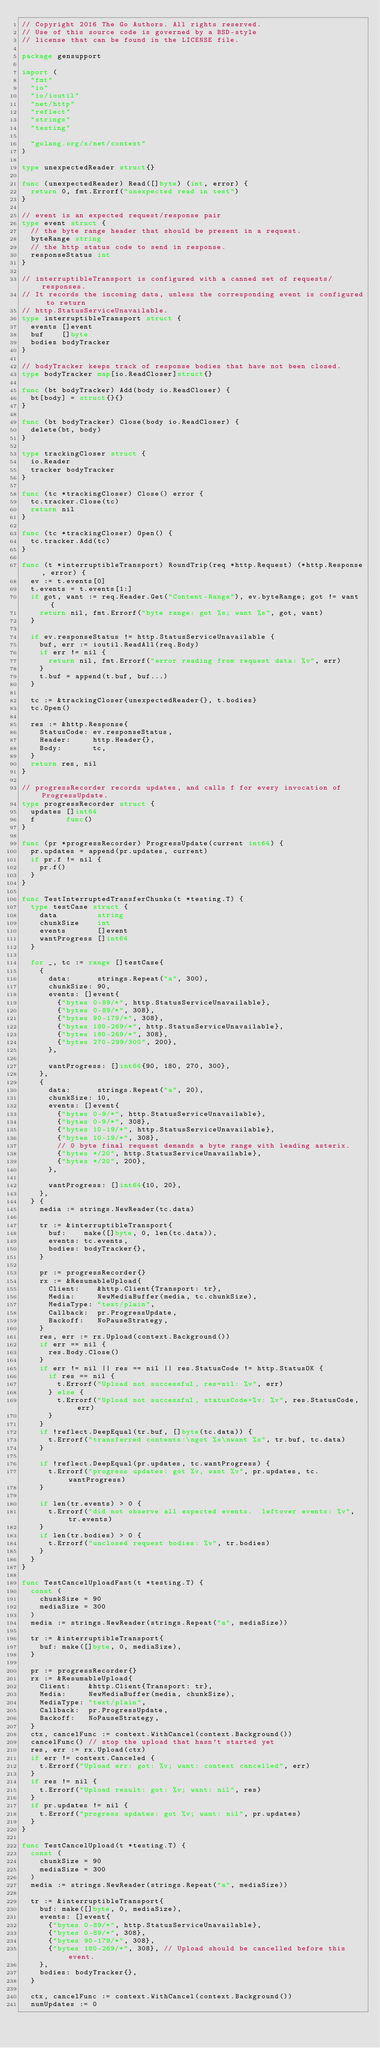<code> <loc_0><loc_0><loc_500><loc_500><_Go_>// Copyright 2016 The Go Authors. All rights reserved.
// Use of this source code is governed by a BSD-style
// license that can be found in the LICENSE file.

package gensupport

import (
	"fmt"
	"io"
	"io/ioutil"
	"net/http"
	"reflect"
	"strings"
	"testing"

	"golang.org/x/net/context"
)

type unexpectedReader struct{}

func (unexpectedReader) Read([]byte) (int, error) {
	return 0, fmt.Errorf("unexpected read in test")
}

// event is an expected request/response pair
type event struct {
	// the byte range header that should be present in a request.
	byteRange string
	// the http status code to send in response.
	responseStatus int
}

// interruptibleTransport is configured with a canned set of requests/responses.
// It records the incoming data, unless the corresponding event is configured to return
// http.StatusServiceUnavailable.
type interruptibleTransport struct {
	events []event
	buf    []byte
	bodies bodyTracker
}

// bodyTracker keeps track of response bodies that have not been closed.
type bodyTracker map[io.ReadCloser]struct{}

func (bt bodyTracker) Add(body io.ReadCloser) {
	bt[body] = struct{}{}
}

func (bt bodyTracker) Close(body io.ReadCloser) {
	delete(bt, body)
}

type trackingCloser struct {
	io.Reader
	tracker bodyTracker
}

func (tc *trackingCloser) Close() error {
	tc.tracker.Close(tc)
	return nil
}

func (tc *trackingCloser) Open() {
	tc.tracker.Add(tc)
}

func (t *interruptibleTransport) RoundTrip(req *http.Request) (*http.Response, error) {
	ev := t.events[0]
	t.events = t.events[1:]
	if got, want := req.Header.Get("Content-Range"), ev.byteRange; got != want {
		return nil, fmt.Errorf("byte range: got %s; want %s", got, want)
	}

	if ev.responseStatus != http.StatusServiceUnavailable {
		buf, err := ioutil.ReadAll(req.Body)
		if err != nil {
			return nil, fmt.Errorf("error reading from request data: %v", err)
		}
		t.buf = append(t.buf, buf...)
	}

	tc := &trackingCloser{unexpectedReader{}, t.bodies}
	tc.Open()

	res := &http.Response{
		StatusCode: ev.responseStatus,
		Header:     http.Header{},
		Body:       tc,
	}
	return res, nil
}

// progressRecorder records updates, and calls f for every invocation of ProgressUpdate.
type progressRecorder struct {
	updates []int64
	f       func()
}

func (pr *progressRecorder) ProgressUpdate(current int64) {
	pr.updates = append(pr.updates, current)
	if pr.f != nil {
		pr.f()
	}
}

func TestInterruptedTransferChunks(t *testing.T) {
	type testCase struct {
		data         string
		chunkSize    int
		events       []event
		wantProgress []int64
	}

	for _, tc := range []testCase{
		{
			data:      strings.Repeat("a", 300),
			chunkSize: 90,
			events: []event{
				{"bytes 0-89/*", http.StatusServiceUnavailable},
				{"bytes 0-89/*", 308},
				{"bytes 90-179/*", 308},
				{"bytes 180-269/*", http.StatusServiceUnavailable},
				{"bytes 180-269/*", 308},
				{"bytes 270-299/300", 200},
			},

			wantProgress: []int64{90, 180, 270, 300},
		},
		{
			data:      strings.Repeat("a", 20),
			chunkSize: 10,
			events: []event{
				{"bytes 0-9/*", http.StatusServiceUnavailable},
				{"bytes 0-9/*", 308},
				{"bytes 10-19/*", http.StatusServiceUnavailable},
				{"bytes 10-19/*", 308},
				// 0 byte final request demands a byte range with leading asterix.
				{"bytes */20", http.StatusServiceUnavailable},
				{"bytes */20", 200},
			},

			wantProgress: []int64{10, 20},
		},
	} {
		media := strings.NewReader(tc.data)

		tr := &interruptibleTransport{
			buf:    make([]byte, 0, len(tc.data)),
			events: tc.events,
			bodies: bodyTracker{},
		}

		pr := progressRecorder{}
		rx := &ResumableUpload{
			Client:    &http.Client{Transport: tr},
			Media:     NewMediaBuffer(media, tc.chunkSize),
			MediaType: "text/plain",
			Callback:  pr.ProgressUpdate,
			Backoff:   NoPauseStrategy,
		}
		res, err := rx.Upload(context.Background())
		if err == nil {
			res.Body.Close()
		}
		if err != nil || res == nil || res.StatusCode != http.StatusOK {
			if res == nil {
				t.Errorf("Upload not successful, res=nil: %v", err)
			} else {
				t.Errorf("Upload not successful, statusCode=%v: %v", res.StatusCode, err)
			}
		}
		if !reflect.DeepEqual(tr.buf, []byte(tc.data)) {
			t.Errorf("transferred contents:\ngot %s\nwant %s", tr.buf, tc.data)
		}

		if !reflect.DeepEqual(pr.updates, tc.wantProgress) {
			t.Errorf("progress updates: got %v, want %v", pr.updates, tc.wantProgress)
		}

		if len(tr.events) > 0 {
			t.Errorf("did not observe all expected events.  leftover events: %v", tr.events)
		}
		if len(tr.bodies) > 0 {
			t.Errorf("unclosed request bodies: %v", tr.bodies)
		}
	}
}

func TestCancelUploadFast(t *testing.T) {
	const (
		chunkSize = 90
		mediaSize = 300
	)
	media := strings.NewReader(strings.Repeat("a", mediaSize))

	tr := &interruptibleTransport{
		buf: make([]byte, 0, mediaSize),
	}

	pr := progressRecorder{}
	rx := &ResumableUpload{
		Client:    &http.Client{Transport: tr},
		Media:     NewMediaBuffer(media, chunkSize),
		MediaType: "text/plain",
		Callback:  pr.ProgressUpdate,
		Backoff:   NoPauseStrategy,
	}
	ctx, cancelFunc := context.WithCancel(context.Background())
	cancelFunc() // stop the upload that hasn't started yet
	res, err := rx.Upload(ctx)
	if err != context.Canceled {
		t.Errorf("Upload err: got: %v; want: context cancelled", err)
	}
	if res != nil {
		t.Errorf("Upload result: got: %v; want: nil", res)
	}
	if pr.updates != nil {
		t.Errorf("progress updates: got %v; want: nil", pr.updates)
	}
}

func TestCancelUpload(t *testing.T) {
	const (
		chunkSize = 90
		mediaSize = 300
	)
	media := strings.NewReader(strings.Repeat("a", mediaSize))

	tr := &interruptibleTransport{
		buf: make([]byte, 0, mediaSize),
		events: []event{
			{"bytes 0-89/*", http.StatusServiceUnavailable},
			{"bytes 0-89/*", 308},
			{"bytes 90-179/*", 308},
			{"bytes 180-269/*", 308}, // Upload should be cancelled before this event.
		},
		bodies: bodyTracker{},
	}

	ctx, cancelFunc := context.WithCancel(context.Background())
	numUpdates := 0
</code> 